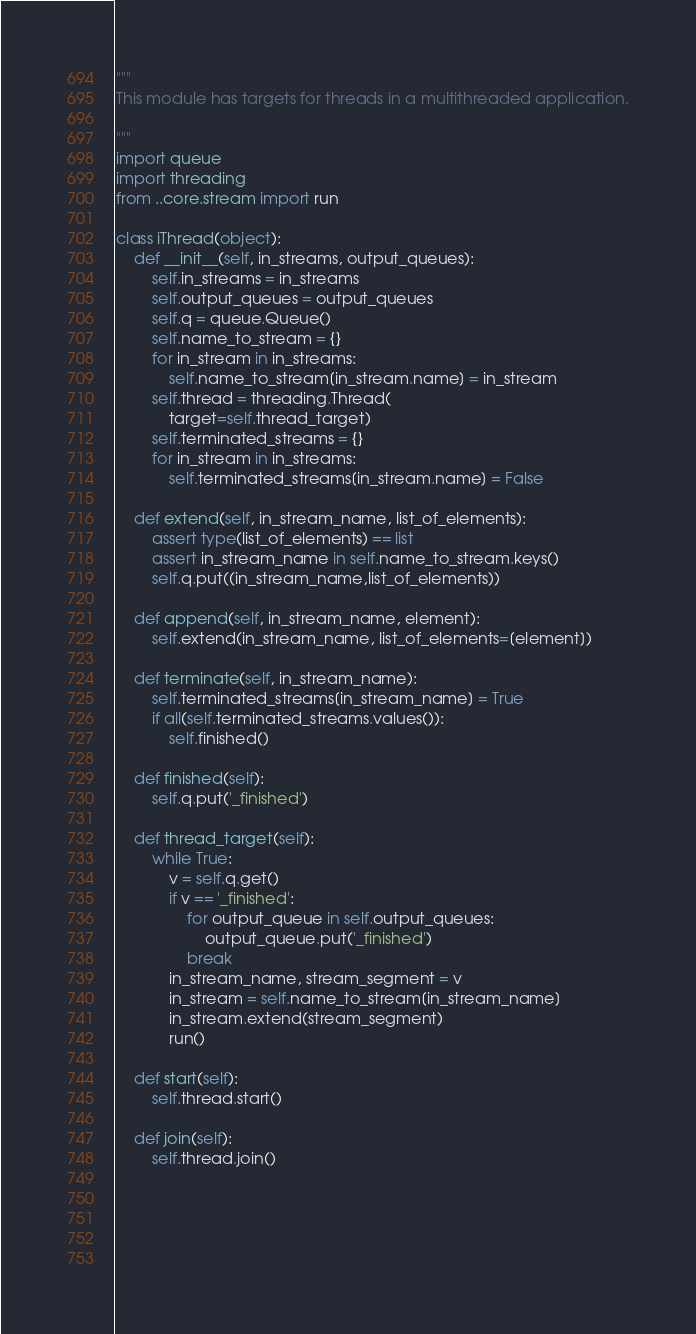Convert code to text. <code><loc_0><loc_0><loc_500><loc_500><_Python_>"""
This module has targets for threads in a multithreaded application.

"""
import queue
import threading
from ..core.stream import run

class iThread(object):
    def __init__(self, in_streams, output_queues):
        self.in_streams = in_streams
        self.output_queues = output_queues
        self.q = queue.Queue()
        self.name_to_stream = {}
        for in_stream in in_streams:
            self.name_to_stream[in_stream.name] = in_stream
        self.thread = threading.Thread(
            target=self.thread_target)
        self.terminated_streams = {}
        for in_stream in in_streams:
            self.terminated_streams[in_stream.name] = False

    def extend(self, in_stream_name, list_of_elements):
        assert type(list_of_elements) == list
        assert in_stream_name in self.name_to_stream.keys()
        self.q.put((in_stream_name,list_of_elements))

    def append(self, in_stream_name, element):
        self.extend(in_stream_name, list_of_elements=[element])

    def terminate(self, in_stream_name):
        self.terminated_streams[in_stream_name] = True
        if all(self.terminated_streams.values()):
            self.finished()

    def finished(self):
        self.q.put('_finished')

    def thread_target(self):
        while True:
            v = self.q.get()
            if v == '_finished':
                for output_queue in self.output_queues:
                    output_queue.put('_finished')
                break
            in_stream_name, stream_segment = v
            in_stream = self.name_to_stream[in_stream_name]
            in_stream.extend(stream_segment)
            run()

    def start(self):
        self.thread.start()

    def join(self):
        self.thread.join()
        
    
        
        
        
</code> 